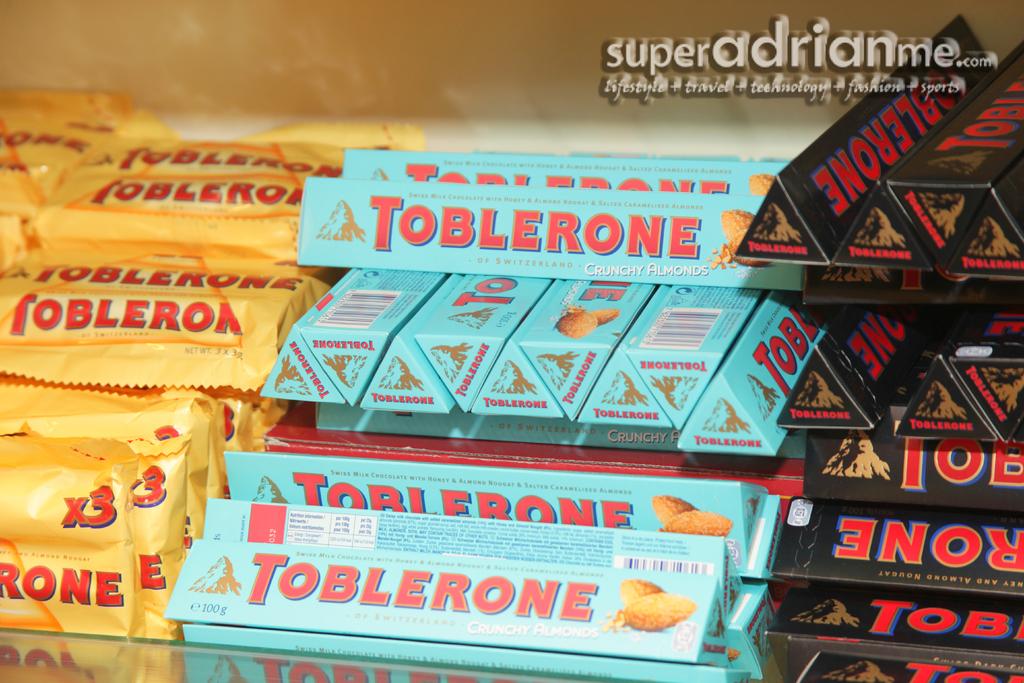What kind of chocolate is this?
Your answer should be very brief. Toblerone. 